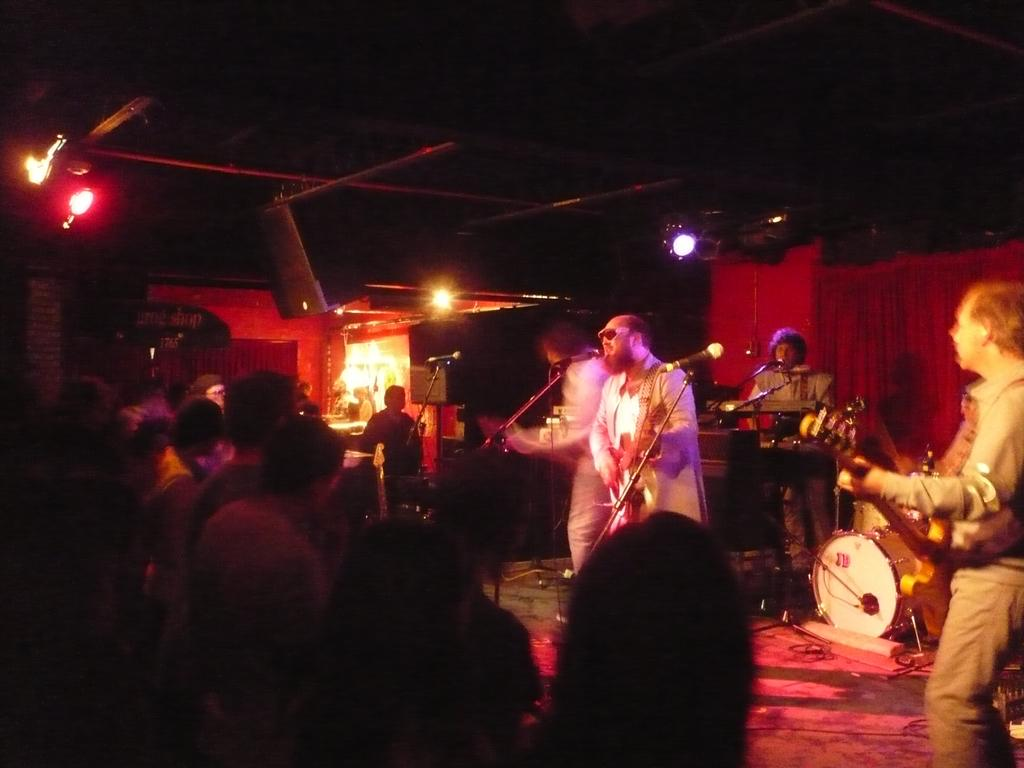How many men are on the stage in the image? There are four men on the stage in the image. What are the men doing on the stage? The men are holding musical instruments and are in front of microphones. Can you describe the audience in the image? Yes, there are people visible in the image. What can be seen in the image that might be used for illumination? There are lights in the image. What type of stew is being served backstage during the performance? There is no information about stew or any food being served in the image. How hot is the temperature on the stage during the performance? The temperature cannot be determined from the image alone. 